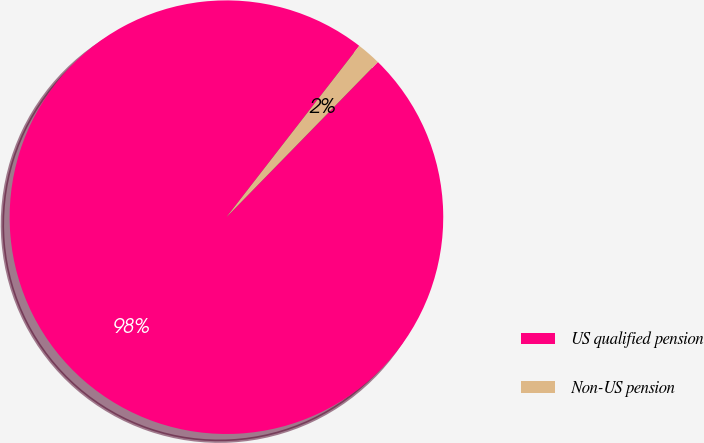Convert chart to OTSL. <chart><loc_0><loc_0><loc_500><loc_500><pie_chart><fcel>US qualified pension<fcel>Non-US pension<nl><fcel>98.19%<fcel>1.81%<nl></chart> 